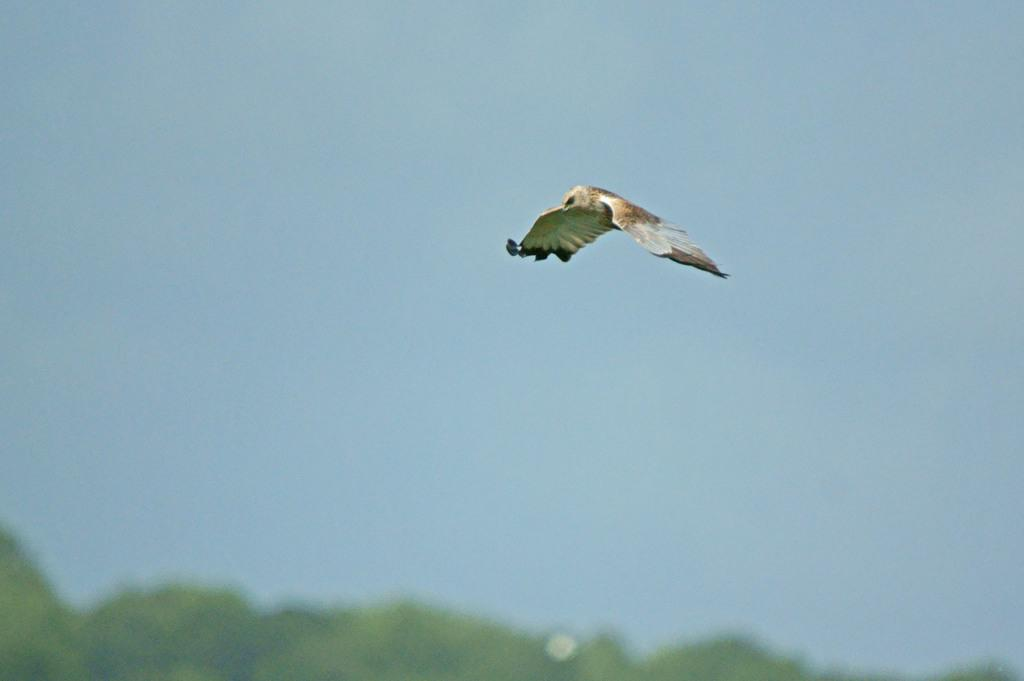What is the main subject of the image? There is a bird flying in the air in the image. What can be seen at the bottom of the image? There are trees at the bottom of the image. What is visible in the background of the image? The sky is visible in the background. How many cakes are being carried by the beggar in the image? There is no beggar or cakes present in the image. What type of sack is the bird carrying in the image? There is no sack present in the image; the bird is simply flying in the air. 